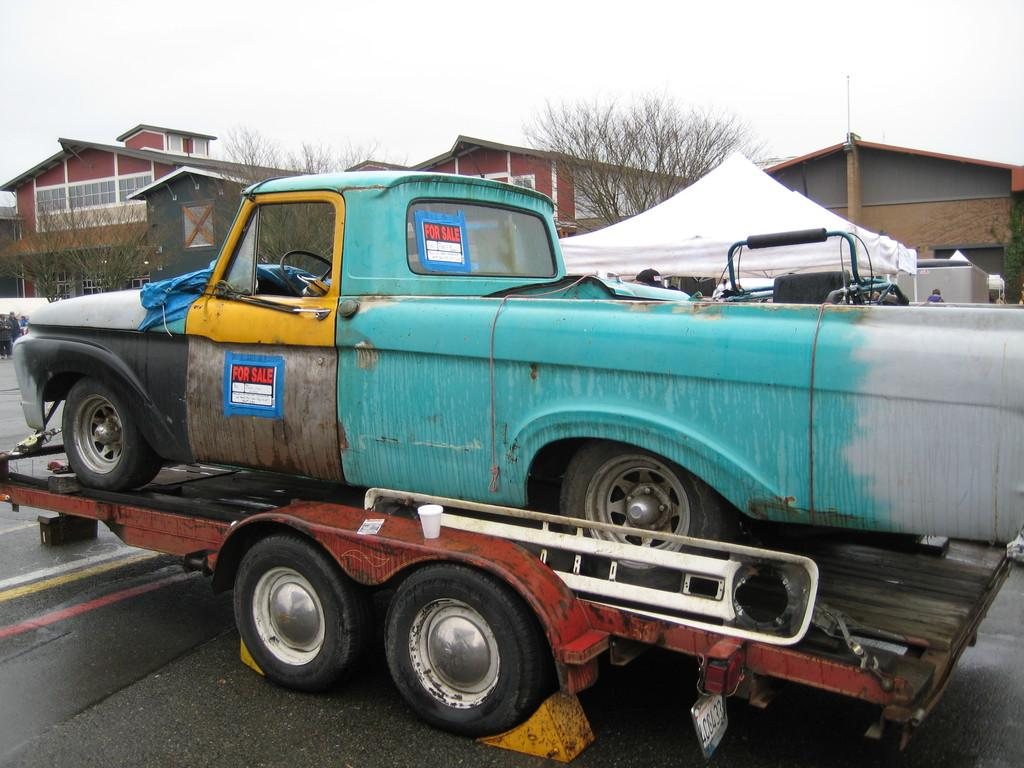What is the main subject of the image? The main subject of the image is a car on a truck in the center of the image. What can be seen in the background of the image? There are trees, a tent, buildings, and the sky visible in the background of the image. Can you tell me how many bees are buzzing around the car on the truck in the image? There are no bees present in the image; the focus is on the car on the truck and the background elements. 